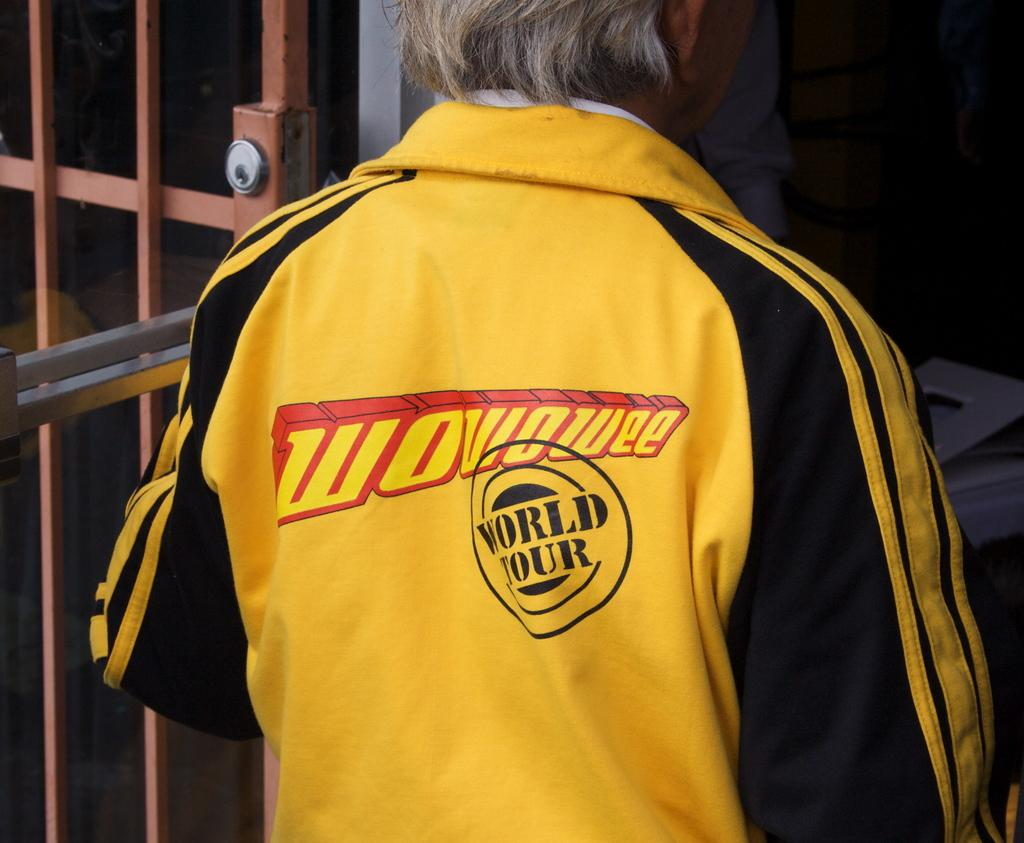<image>
Create a compact narrative representing the image presented. Man with a yellow coat that ha woviowee World Tour on it. 